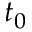Convert formula to latex. <formula><loc_0><loc_0><loc_500><loc_500>t _ { 0 }</formula> 